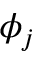Convert formula to latex. <formula><loc_0><loc_0><loc_500><loc_500>\phi _ { j }</formula> 